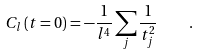Convert formula to latex. <formula><loc_0><loc_0><loc_500><loc_500>C _ { l } \left ( t = 0 \right ) = - \frac { 1 } { l ^ { 4 } } \sum _ { j } { \frac { 1 } { t _ { j } ^ { 2 } } } \quad .</formula> 